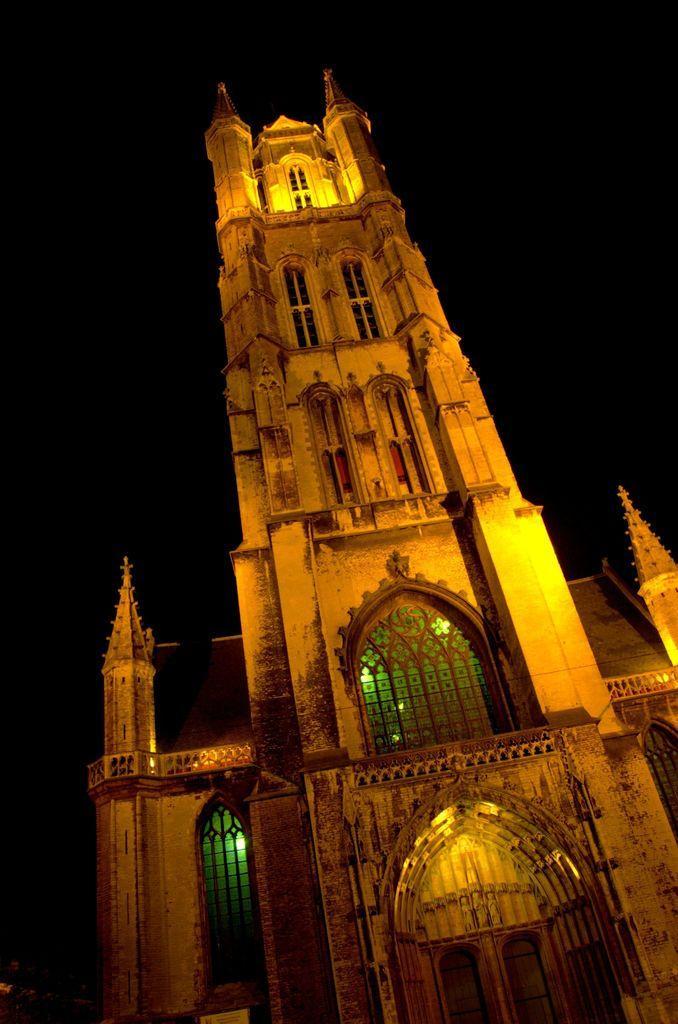In one or two sentences, can you explain what this image depicts? In the image there is a building with pillars, arches, glass windows and doors. Behind the building there is a dark background. 